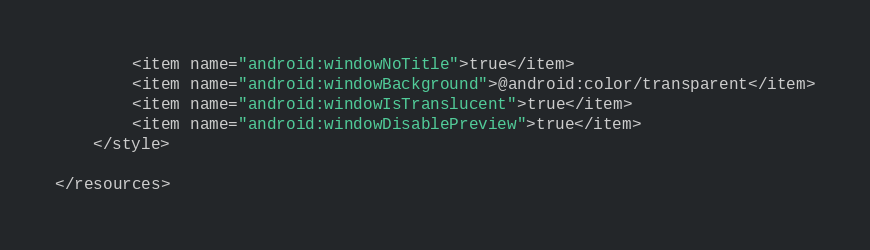<code> <loc_0><loc_0><loc_500><loc_500><_XML_>        <item name="android:windowNoTitle">true</item>
        <item name="android:windowBackground">@android:color/transparent</item>
        <item name="android:windowIsTranslucent">true</item>
        <item name="android:windowDisablePreview">true</item>
    </style>

</resources></code> 